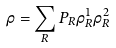<formula> <loc_0><loc_0><loc_500><loc_500>\rho = \sum _ { R } P _ { R } \rho _ { R } ^ { 1 } \rho _ { R } ^ { 2 }</formula> 